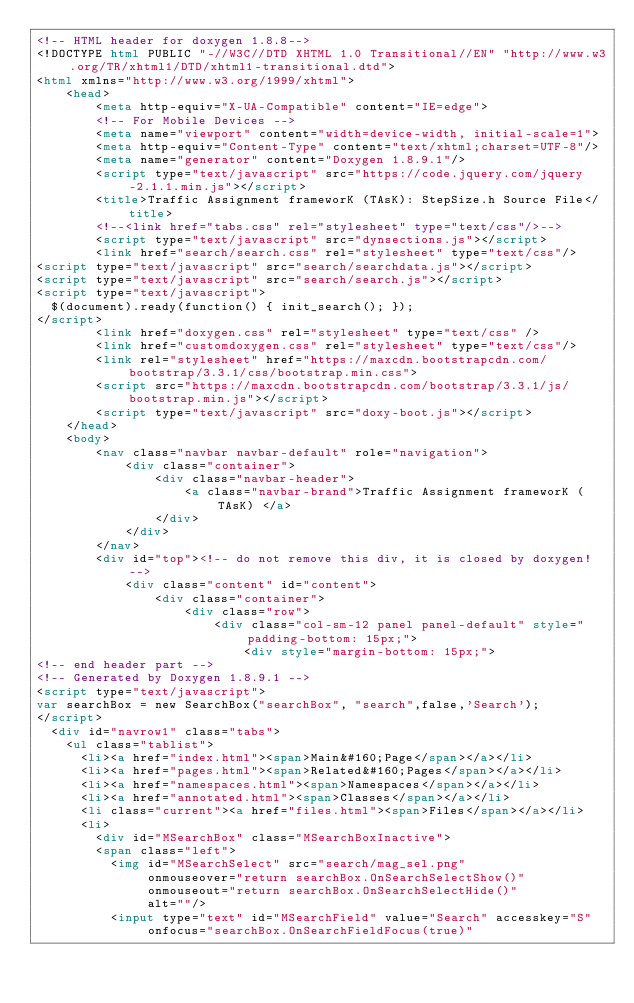<code> <loc_0><loc_0><loc_500><loc_500><_HTML_><!-- HTML header for doxygen 1.8.8-->
<!DOCTYPE html PUBLIC "-//W3C//DTD XHTML 1.0 Transitional//EN" "http://www.w3.org/TR/xhtml1/DTD/xhtml1-transitional.dtd">
<html xmlns="http://www.w3.org/1999/xhtml">
    <head>
        <meta http-equiv="X-UA-Compatible" content="IE=edge">
        <!-- For Mobile Devices -->
        <meta name="viewport" content="width=device-width, initial-scale=1">
        <meta http-equiv="Content-Type" content="text/xhtml;charset=UTF-8"/>
        <meta name="generator" content="Doxygen 1.8.9.1"/>
        <script type="text/javascript" src="https://code.jquery.com/jquery-2.1.1.min.js"></script>
        <title>Traffic Assignment frameworK (TAsK): StepSize.h Source File</title>
        <!--<link href="tabs.css" rel="stylesheet" type="text/css"/>-->
        <script type="text/javascript" src="dynsections.js"></script>
        <link href="search/search.css" rel="stylesheet" type="text/css"/>
<script type="text/javascript" src="search/searchdata.js"></script>
<script type="text/javascript" src="search/search.js"></script>
<script type="text/javascript">
  $(document).ready(function() { init_search(); });
</script>
        <link href="doxygen.css" rel="stylesheet" type="text/css" />
        <link href="customdoxygen.css" rel="stylesheet" type="text/css"/>
        <link rel="stylesheet" href="https://maxcdn.bootstrapcdn.com/bootstrap/3.3.1/css/bootstrap.min.css">
        <script src="https://maxcdn.bootstrapcdn.com/bootstrap/3.3.1/js/bootstrap.min.js"></script>
        <script type="text/javascript" src="doxy-boot.js"></script>
    </head>
    <body>
        <nav class="navbar navbar-default" role="navigation">
            <div class="container">
                <div class="navbar-header">
                    <a class="navbar-brand">Traffic Assignment frameworK (TAsK) </a>
                </div>
            </div>
        </nav>
        <div id="top"><!-- do not remove this div, it is closed by doxygen! -->
            <div class="content" id="content">
                <div class="container">
                    <div class="row">
                        <div class="col-sm-12 panel panel-default" style="padding-bottom: 15px;">
                            <div style="margin-bottom: 15px;">
<!-- end header part -->
<!-- Generated by Doxygen 1.8.9.1 -->
<script type="text/javascript">
var searchBox = new SearchBox("searchBox", "search",false,'Search');
</script>
  <div id="navrow1" class="tabs">
    <ul class="tablist">
      <li><a href="index.html"><span>Main&#160;Page</span></a></li>
      <li><a href="pages.html"><span>Related&#160;Pages</span></a></li>
      <li><a href="namespaces.html"><span>Namespaces</span></a></li>
      <li><a href="annotated.html"><span>Classes</span></a></li>
      <li class="current"><a href="files.html"><span>Files</span></a></li>
      <li>
        <div id="MSearchBox" class="MSearchBoxInactive">
        <span class="left">
          <img id="MSearchSelect" src="search/mag_sel.png"
               onmouseover="return searchBox.OnSearchSelectShow()"
               onmouseout="return searchBox.OnSearchSelectHide()"
               alt=""/>
          <input type="text" id="MSearchField" value="Search" accesskey="S"
               onfocus="searchBox.OnSearchFieldFocus(true)" </code> 